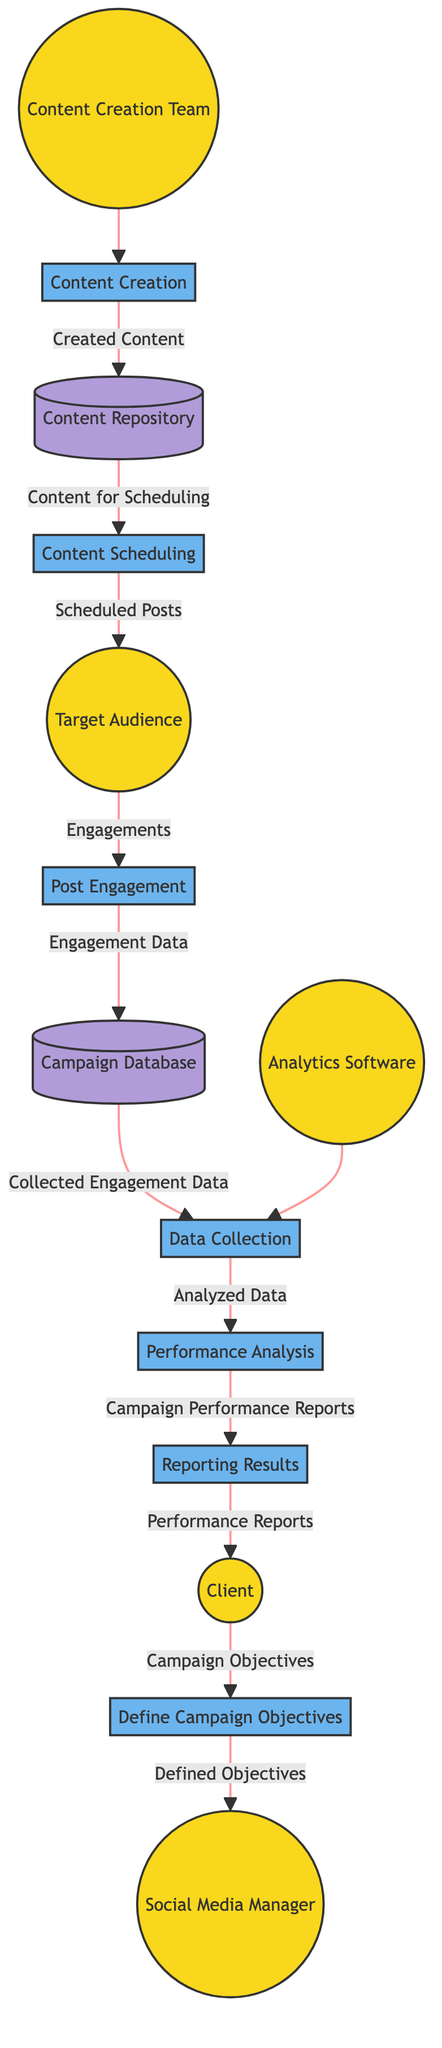What is the first process in the workflow? The first process in the workflow is defined by P1, which is "Define Campaign Objectives." This step is where the Client and Social Media Manager set the goals for the PR campaign.
Answer: Define Campaign Objectives Who interacts with the posts during the campaign? The Target Audience interacts with the posts. This engagement occurs at the P4 process in the workflow.
Answer: Target Audience How many data stores are present in the diagram? There are two data stores in the diagram: the Campaign Database and the Content Repository. Counting these shows that the total is two.
Answer: 2 What type of data does the Analytics Software collect? The Analytics Software collects "Collected Engagement Data" during the P5 process. This is the data gathered from interactions of the Target Audience with the posts.
Answer: Collected Engagement Data Which process is responsible for analyzing engagement data? The process responsible for analyzing engagement data is P6, known as "Performance Analysis." This process takes the data collected in P5 and assesses the campaign's effectiveness.
Answer: Performance Analysis Which entity produces the content for the campaign? The Content Creation Team produces the content for the campaign, as depicted in the P2 process, where they create various media required.
Answer: Content Creation Team Where is the engagement data stored after being collected? The engagement data is stored in the Campaign Database, as shown in the flow from P4 to DS1, where "Engagement Data" is sent for storage.
Answer: Campaign Database What does the Client receive at the end of the workflow? The Client receives "Performance Reports" at the end of the workflow, specifically from the P7 process, which provides detailed reports on how the campaign performed.
Answer: Performance Reports Which process follows the Data Collection process? The process that follows Data Collection (P5) is the Performance Analysis (P6), where the collected engagement data is analyzed to evaluate the campaign's success.
Answer: Performance Analysis 